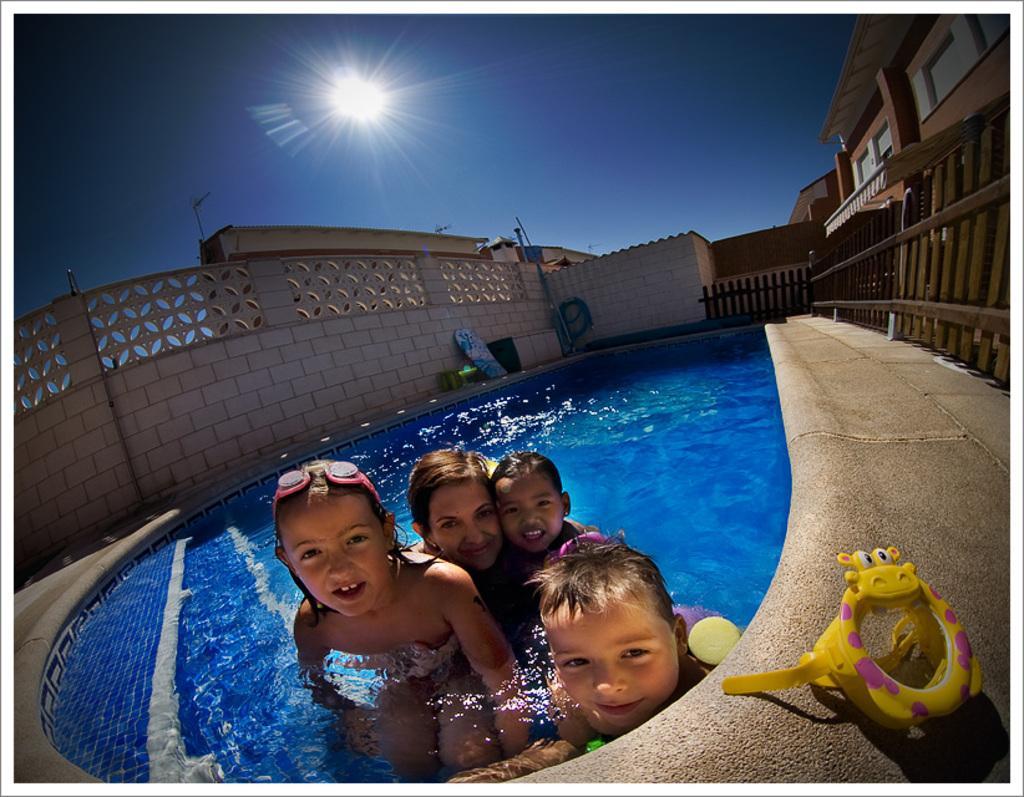Describe this image in one or two sentences. In this image there is a woman and three children's in the swimming pool with a smile on their face, there is a toy and then there is a wall of a building, behind the there is an another building. In the background there is the sky. 